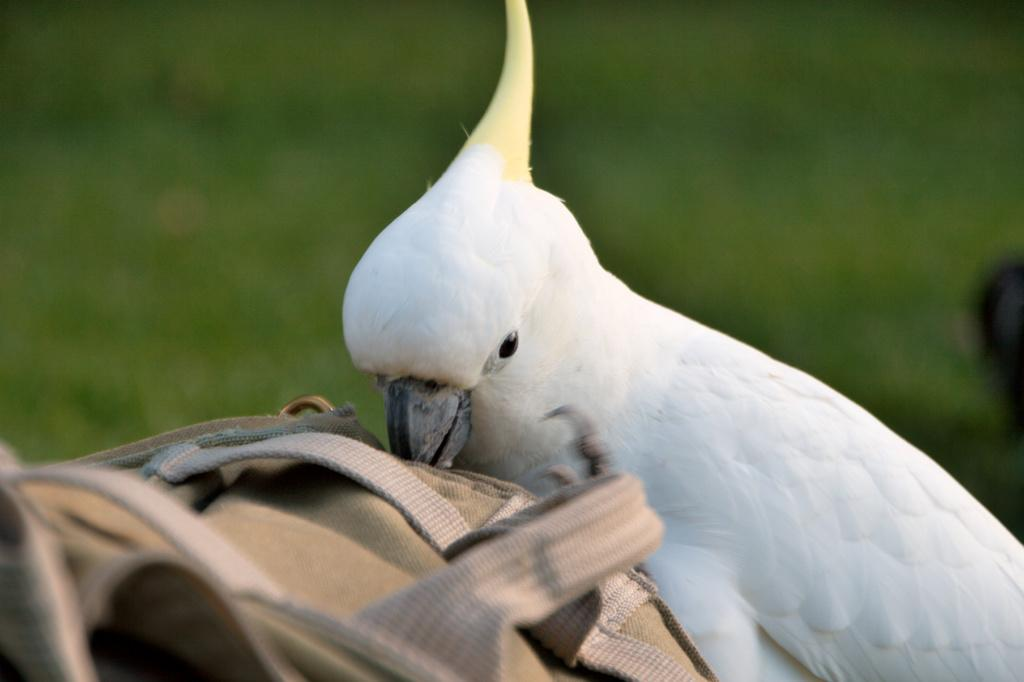What is the brown object in the foreground of the image? There is a brown object in the foreground that resembles a bag. What animal can be seen in the middle of the image? There is a parrot in the middle of the image. What type of environment is visible in the background of the image? There is greenery in the background of the image. What statement does the parrot make in the image? There is no indication in the image that the parrot is making a statement. Parrots are known for their ability to mimic human speech, but without any context or additional information, we cannot determine if the parrot is making a statement or not. 